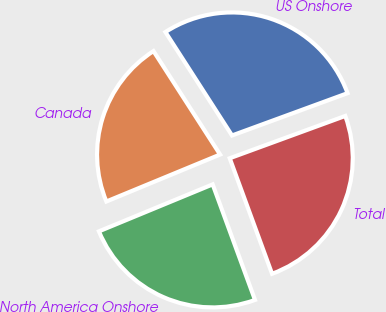<chart> <loc_0><loc_0><loc_500><loc_500><pie_chart><fcel>US Onshore<fcel>Canada<fcel>North America Onshore<fcel>Total<nl><fcel>28.52%<fcel>22.13%<fcel>24.36%<fcel>25.0%<nl></chart> 